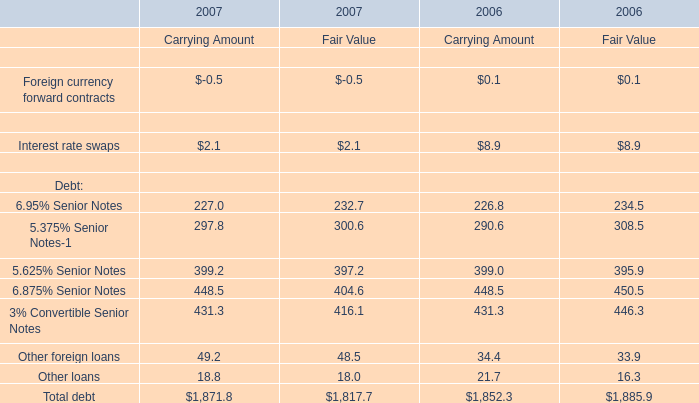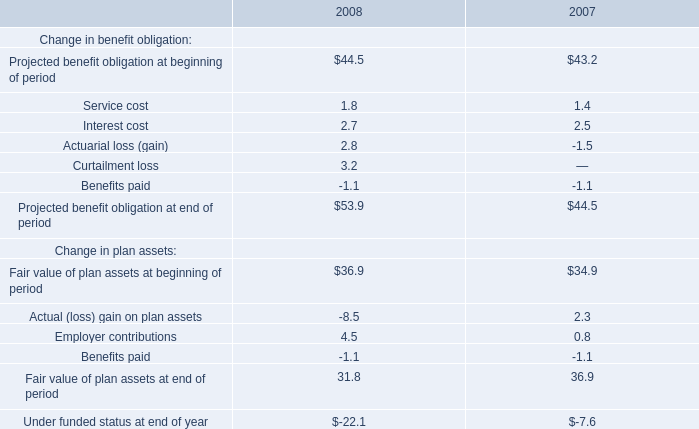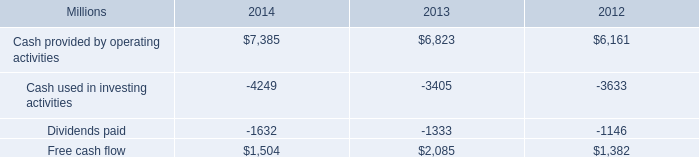what was the percentage change in free cash flow from 2012 to 2013? 
Computations: ((2085 - 1382) / 1382)
Answer: 0.50868. 